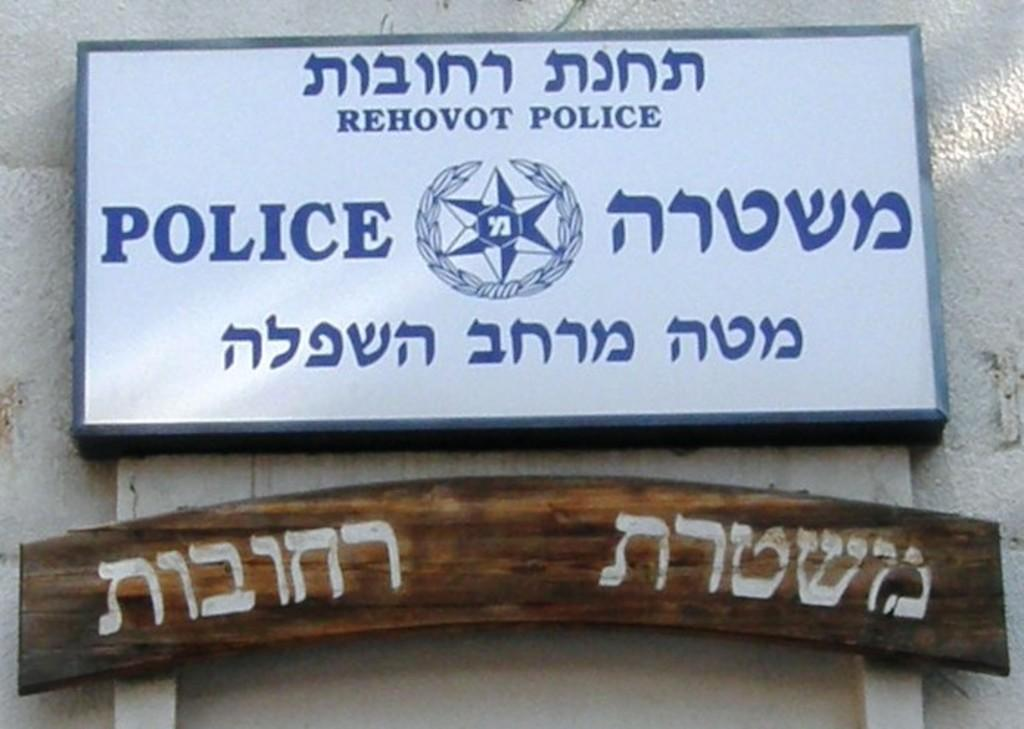<image>
Render a clear and concise summary of the photo. A Star of David is on a white sign that says Police. 